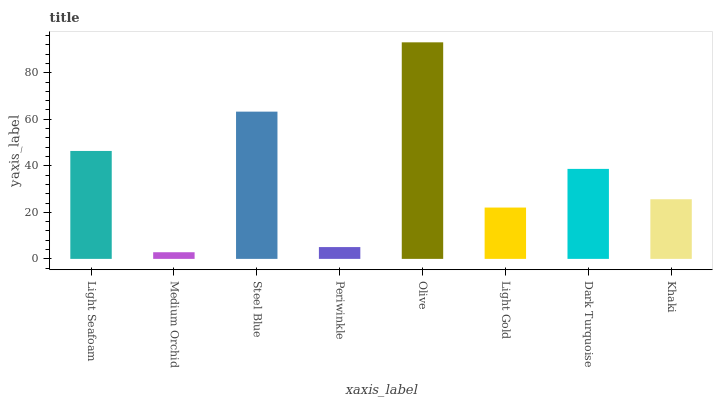Is Medium Orchid the minimum?
Answer yes or no. Yes. Is Olive the maximum?
Answer yes or no. Yes. Is Steel Blue the minimum?
Answer yes or no. No. Is Steel Blue the maximum?
Answer yes or no. No. Is Steel Blue greater than Medium Orchid?
Answer yes or no. Yes. Is Medium Orchid less than Steel Blue?
Answer yes or no. Yes. Is Medium Orchid greater than Steel Blue?
Answer yes or no. No. Is Steel Blue less than Medium Orchid?
Answer yes or no. No. Is Dark Turquoise the high median?
Answer yes or no. Yes. Is Khaki the low median?
Answer yes or no. Yes. Is Olive the high median?
Answer yes or no. No. Is Steel Blue the low median?
Answer yes or no. No. 